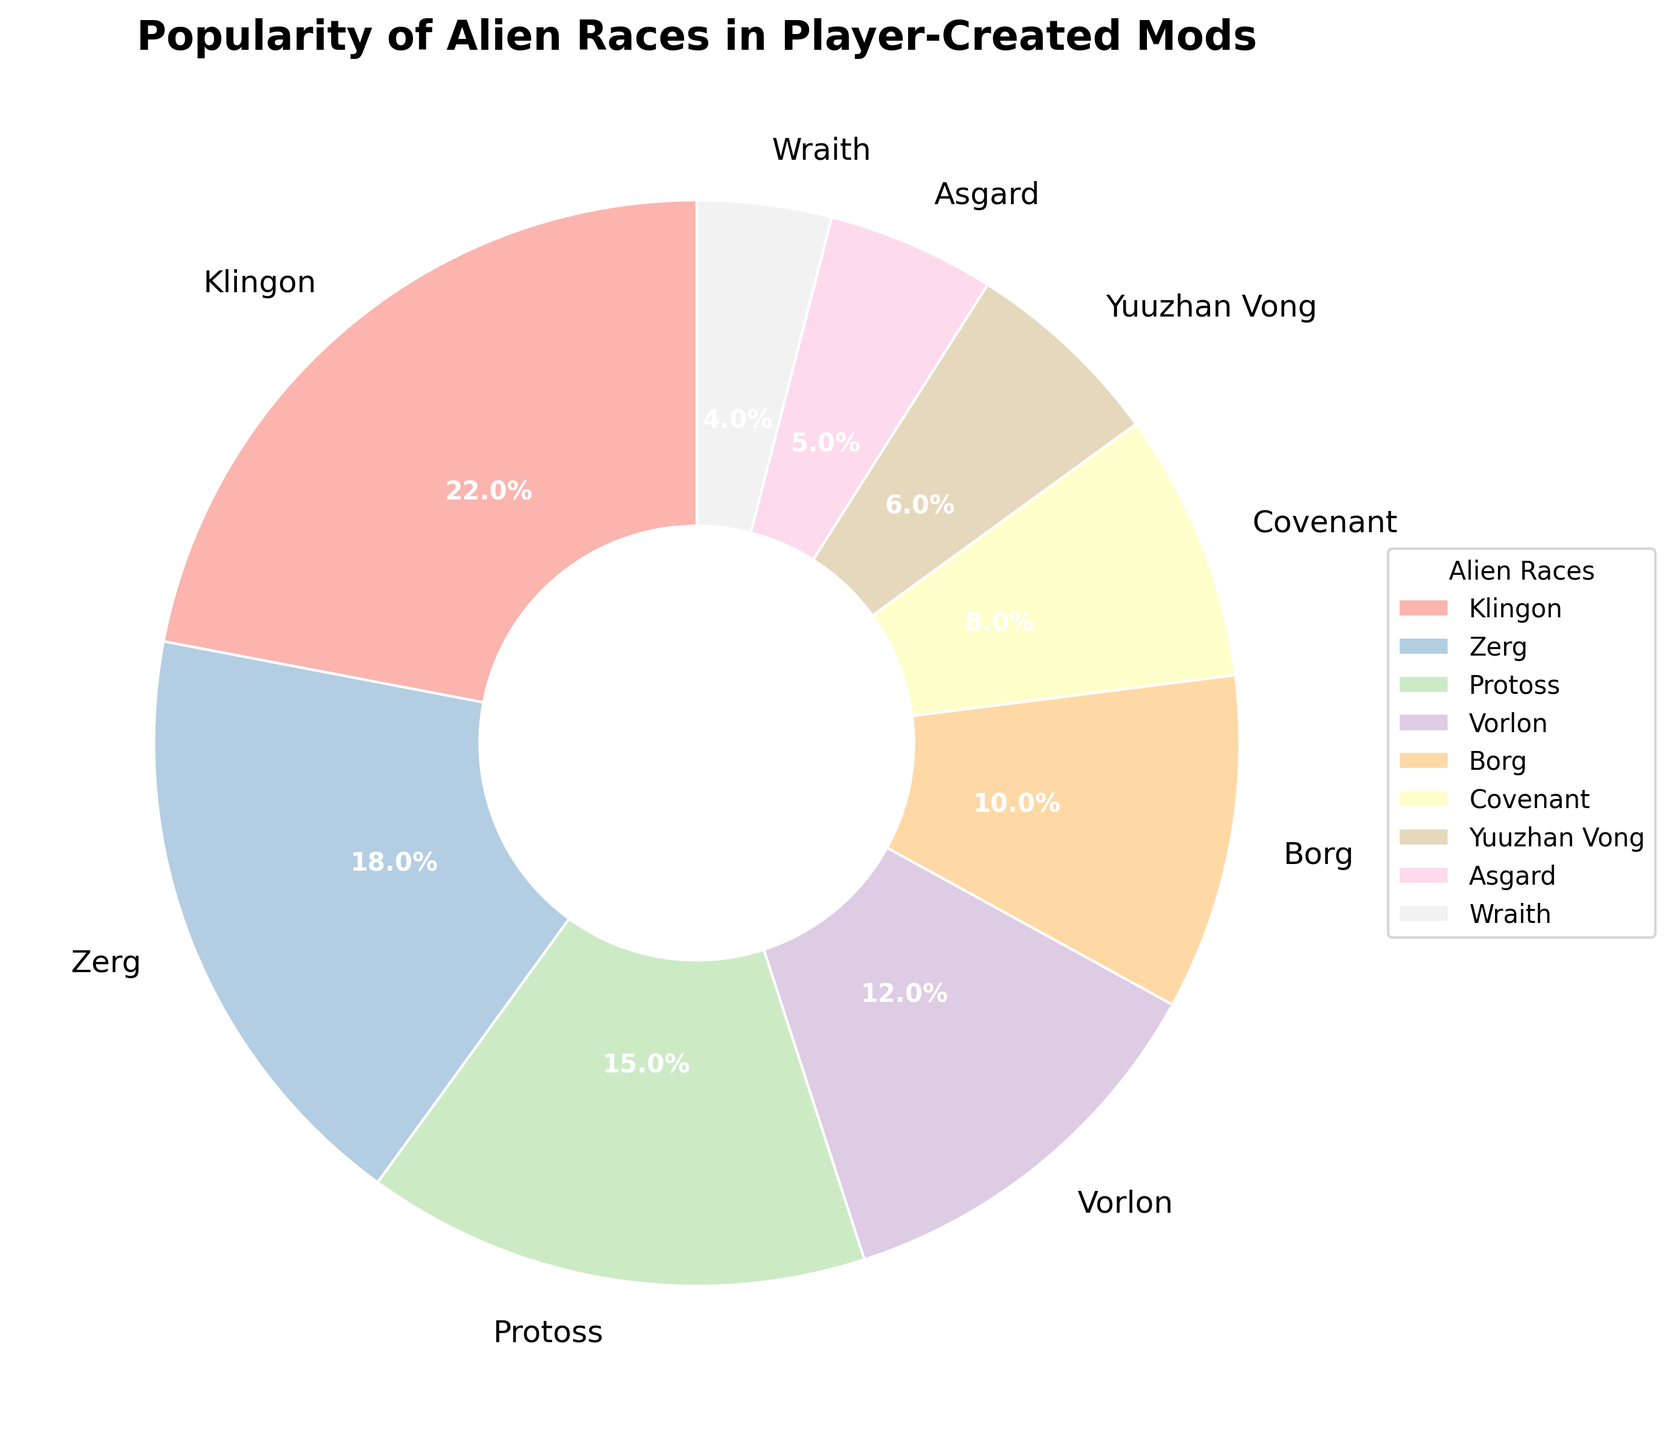What is the most popular alien race in player-created mods? The largest wedge in the pie chart can be identified as the Klingon race with a labeled percentage of 22%. This shows the most popular alien race in player-created mods.
Answer: Klingon Which two races have the closest popularity percentages and what are those percentages? The Zerg and Protoss races have very close popularity percentages, which are 18% and 15%, respectively. They are shown as the second and third largest wedges adjacent to each other in the pie chart.
Answer: Zerg (18%) and Protoss (15%) What is the combined percentage of the three least popular alien races in the player-created mods? The least popular races are the Asgard (5%), Wraith (4%), and Yuuzhan Vong (6%). Adding these percentages: 5 + 4 + 6 = 15%. Thus, the combined percentage is 15%.
Answer: 15% How much more popular are the Klingons compared to the Covenant? The Klingons have a popularity percentage of 22% while the Covenant have 8%. Thus, the difference is calculated as 22 - 8 = 14%.
Answer: 14% Which alien race shares the same color hue visually closest with the Asgard, and what is the percentage of that race? Assuming the pie chart uses pastel variants and similar hues, we inspect visually for the closest colored wedge to the Asgard’s color. Based on proximity, the visually closest race is the Wraith which has a percentage of 4%.
Answer: Wraith (4%) Compare the popularity of the Vorlon and Borg races. What is their percentage difference? The Vorlon race has a 12% share while the Borg has a 10% share. The difference between these percentages is 12 - 10 = 2%.
Answer: 2% Out of the top five popular races, which race comes third in percentage? The top five races by percentage are Klingon (22%), Zerg (18%), Protoss (15%), Vorlon (12%), and Borg (10%). The third in this order is Protoss at 15%.
Answer: Protoss Looking at all the races with percentages between 5% and 10%, how many such races are there? The races falling in this range are the Covenant (8%), Yuuzhan Vong (6%), and Asgard (5%). There are 3 such races.
Answer: 3 How does the combined popularity of the Protoss and Zerg compare to the popularity of the Klingons? Protoss has 15% and Zerg has 18%, combining to 15 + 18 = 33%. Comparing this to Klingons’ 22%: 33% is greater than 22%.
Answer: 33% is greater than 22% Identify any races that have less than 10% but more than 5% popularity. From the chart data, two races fall into this category: Covenant (8%) and Yuuzhan Vong (6%).
Answer: Covenant, Yuuzhan Vong 